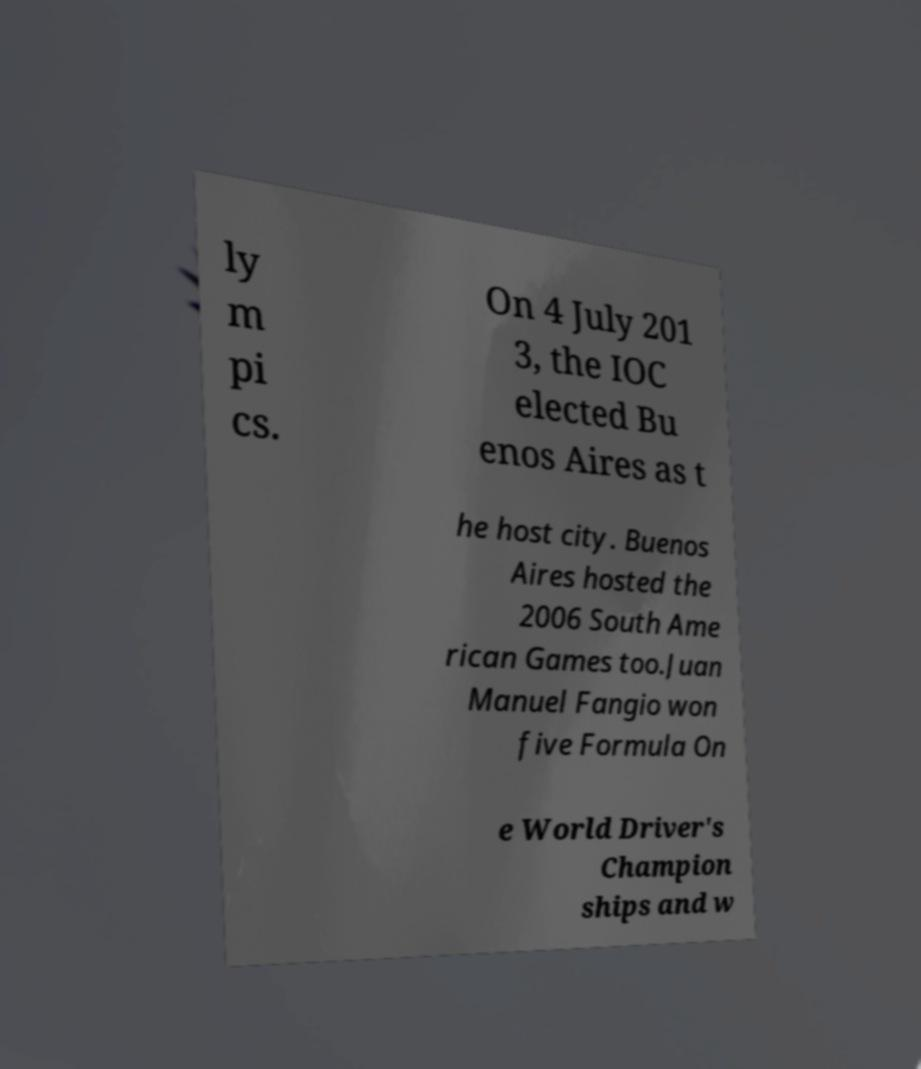Can you accurately transcribe the text from the provided image for me? ly m pi cs. On 4 July 201 3, the IOC elected Bu enos Aires as t he host city. Buenos Aires hosted the 2006 South Ame rican Games too.Juan Manuel Fangio won five Formula On e World Driver's Champion ships and w 